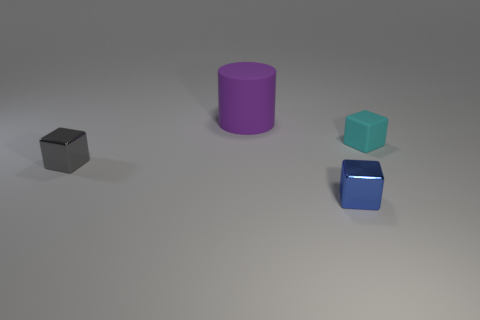Add 3 rubber cubes. How many objects exist? 7 Subtract all small gray shiny cubes. How many cubes are left? 2 Subtract all gray cubes. How many cubes are left? 2 Subtract 0 gray balls. How many objects are left? 4 Subtract all cylinders. How many objects are left? 3 Subtract 1 cylinders. How many cylinders are left? 0 Subtract all gray blocks. Subtract all blue spheres. How many blocks are left? 2 Subtract all cyan cylinders. How many gray cubes are left? 1 Subtract all blue metallic cylinders. Subtract all big matte cylinders. How many objects are left? 3 Add 4 purple objects. How many purple objects are left? 5 